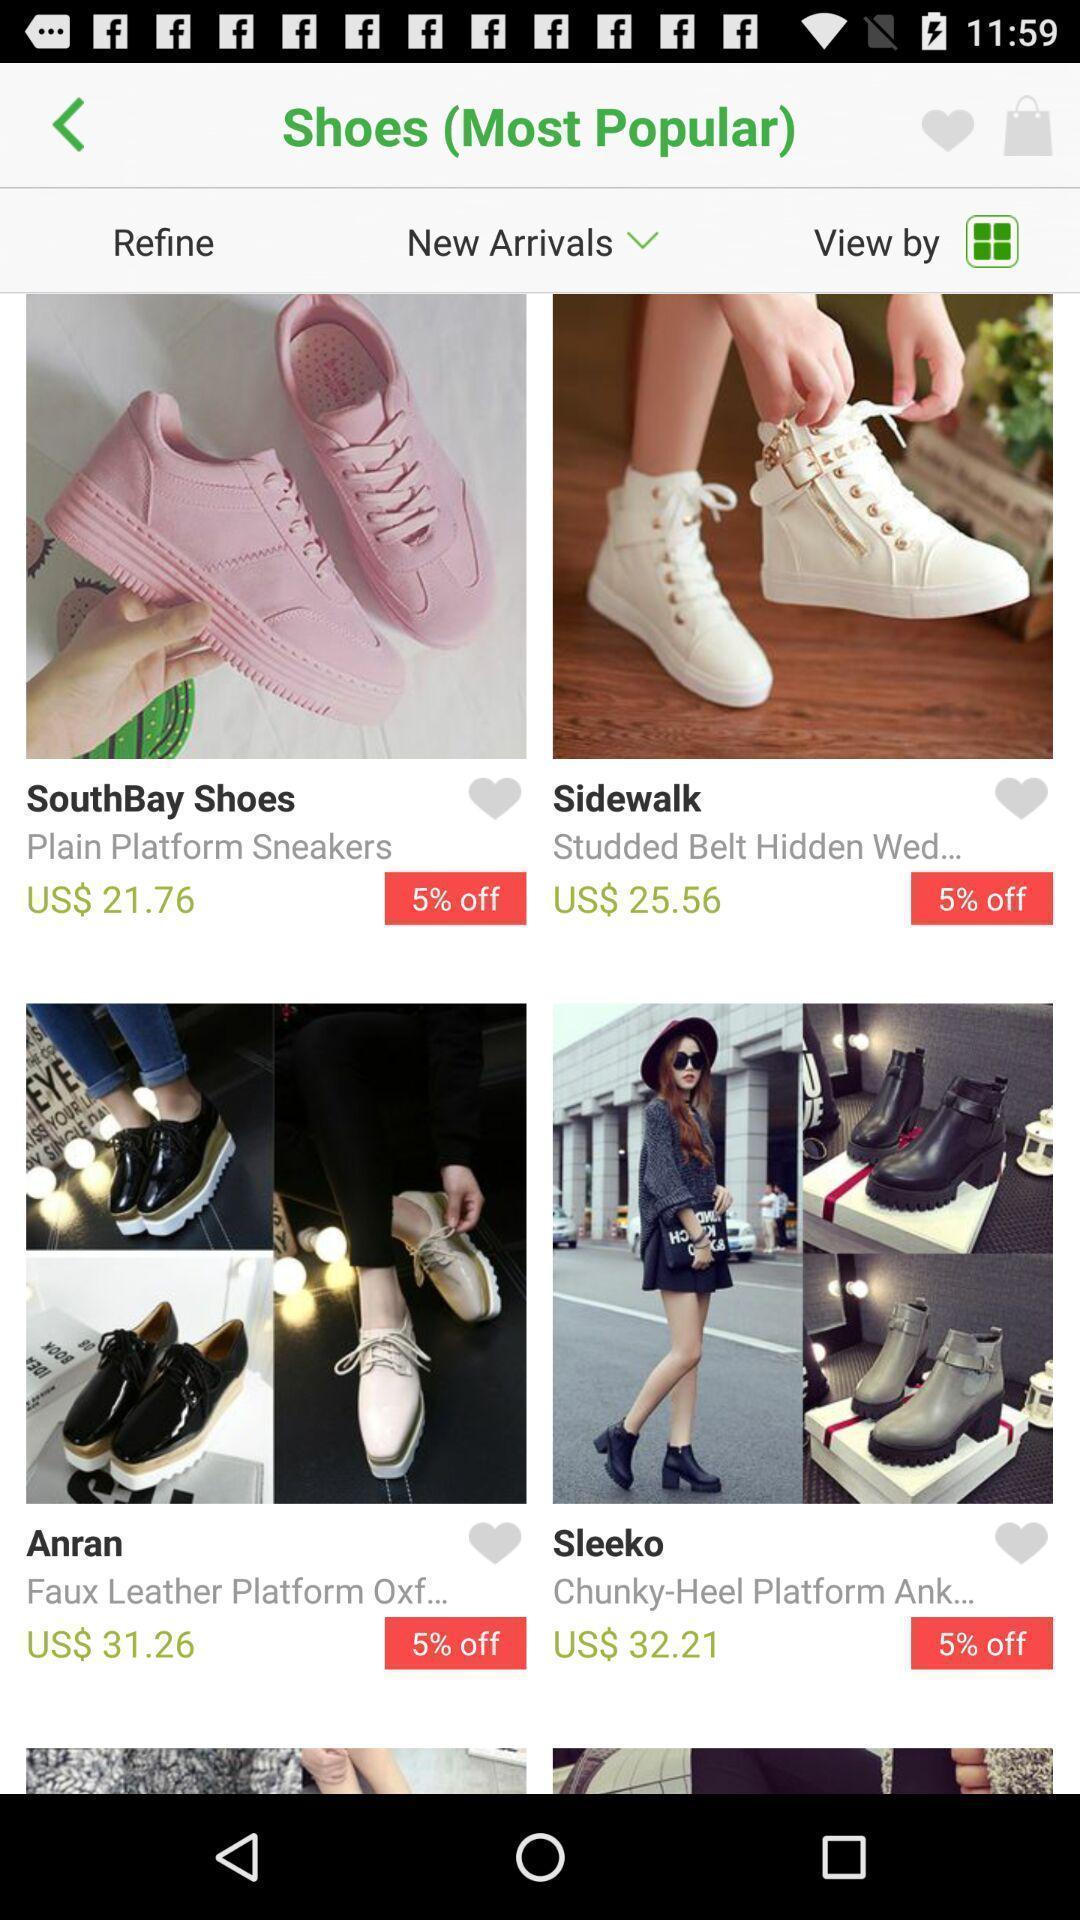Explain what's happening in this screen capture. Shopping page. 